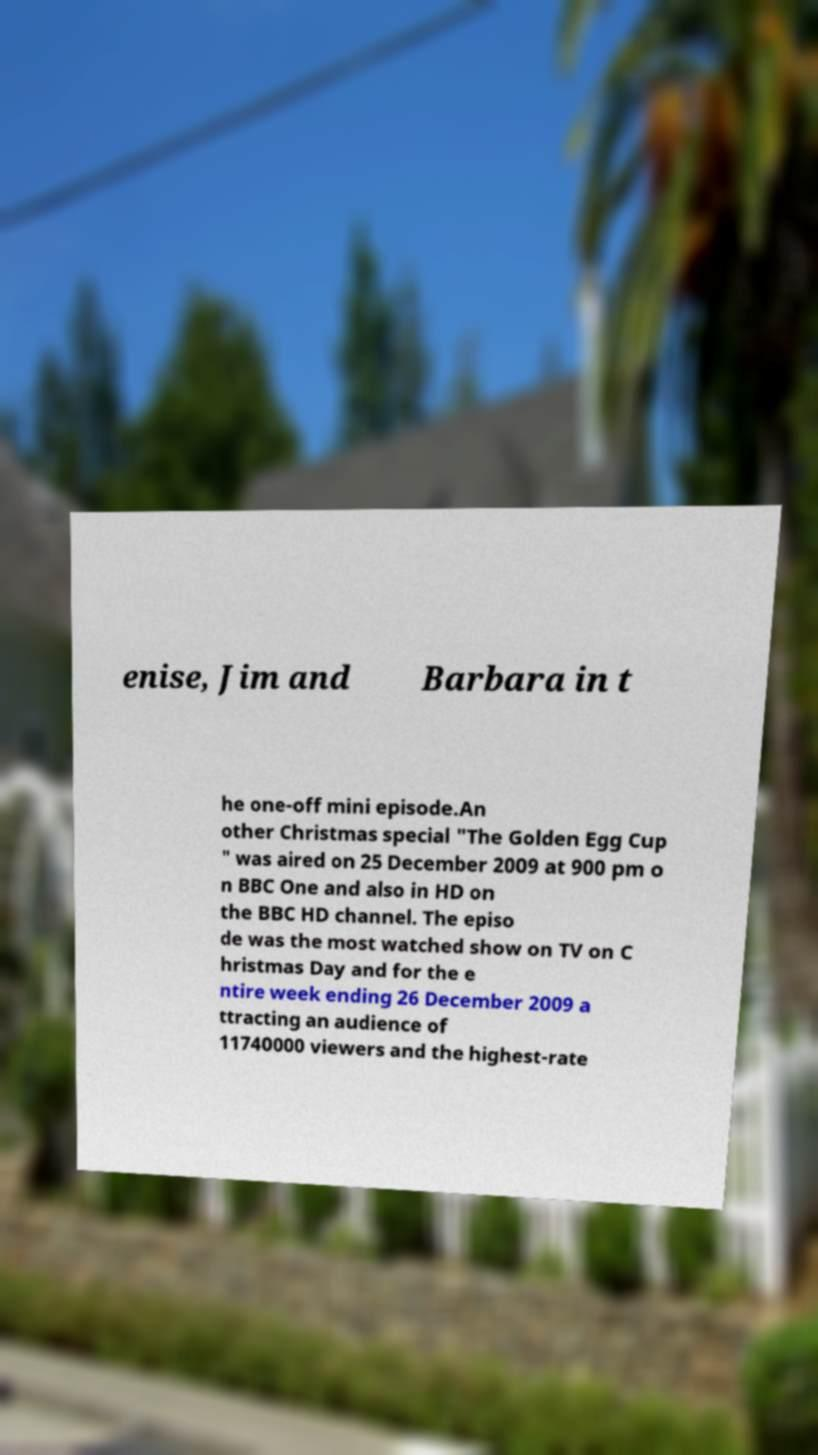Could you extract and type out the text from this image? enise, Jim and Barbara in t he one-off mini episode.An other Christmas special "The Golden Egg Cup " was aired on 25 December 2009 at 900 pm o n BBC One and also in HD on the BBC HD channel. The episo de was the most watched show on TV on C hristmas Day and for the e ntire week ending 26 December 2009 a ttracting an audience of 11740000 viewers and the highest-rate 